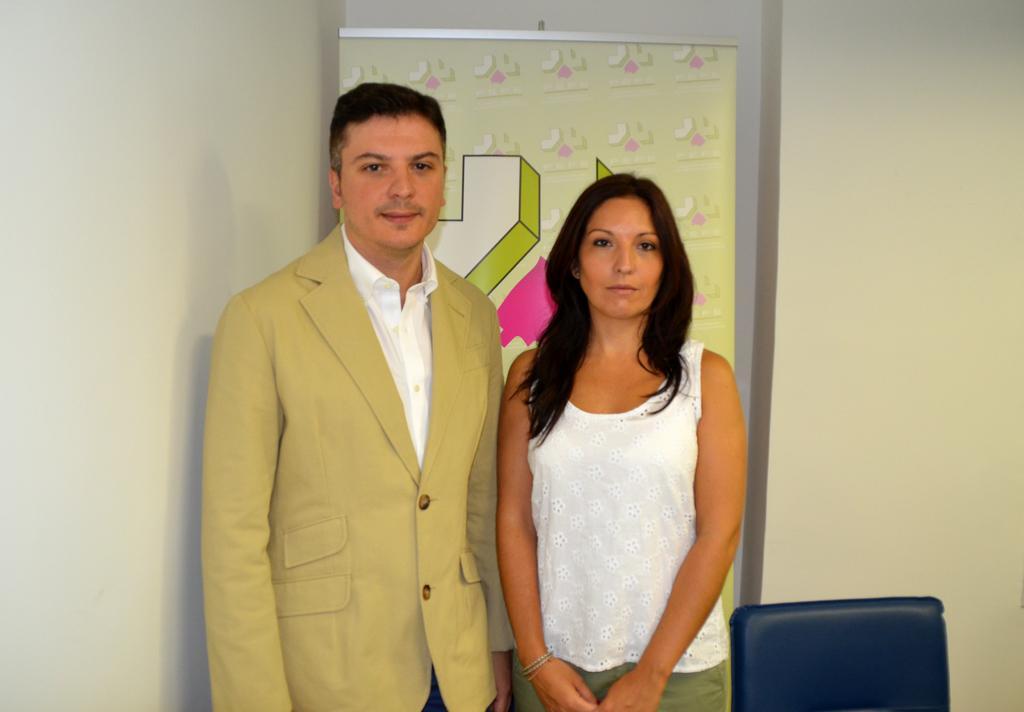Could you give a brief overview of what you see in this image? As we can see in the image there are is wall, banner, chair and two persons standing. The woman is wearing white color dress and the man is wearing cream color jacket. 